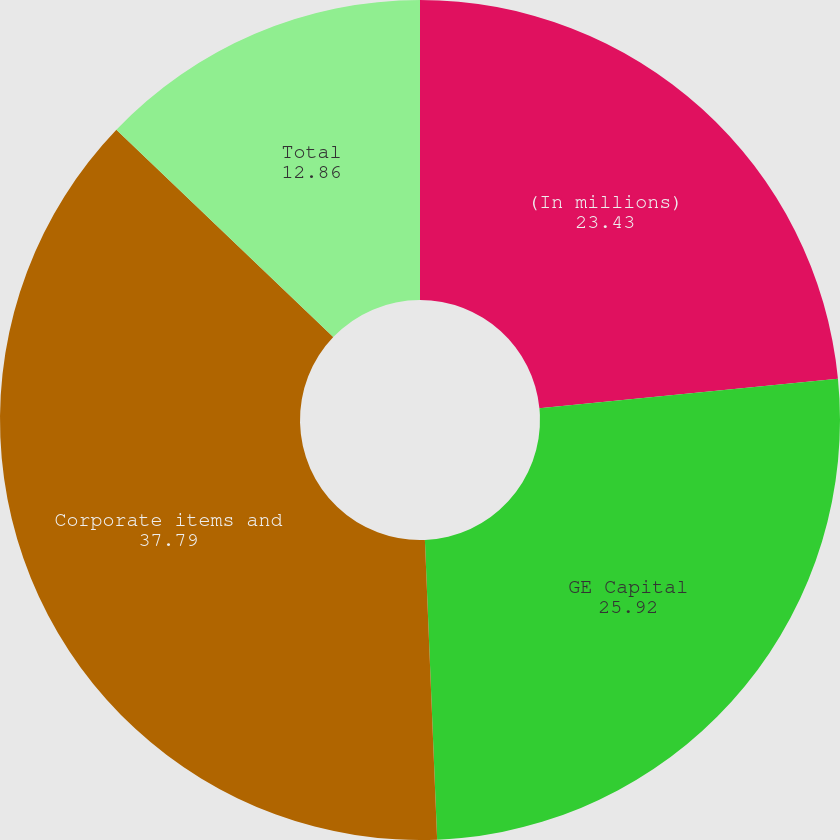Convert chart to OTSL. <chart><loc_0><loc_0><loc_500><loc_500><pie_chart><fcel>(In millions)<fcel>GE Capital<fcel>Corporate items and<fcel>Total<nl><fcel>23.43%<fcel>25.92%<fcel>37.79%<fcel>12.86%<nl></chart> 